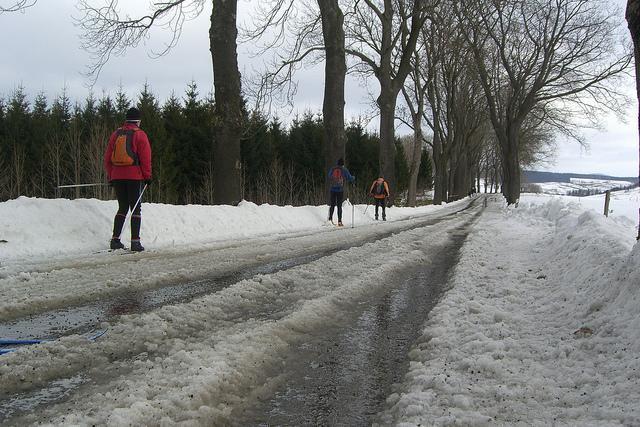What caused the deepest mushiest tracks here?
Select the accurate answer and provide explanation: 'Answer: answer
Rationale: rationale.'
Options: Trains, skiers, bears, automobiles. Answer: automobiles.
Rationale: The cause was cars. 